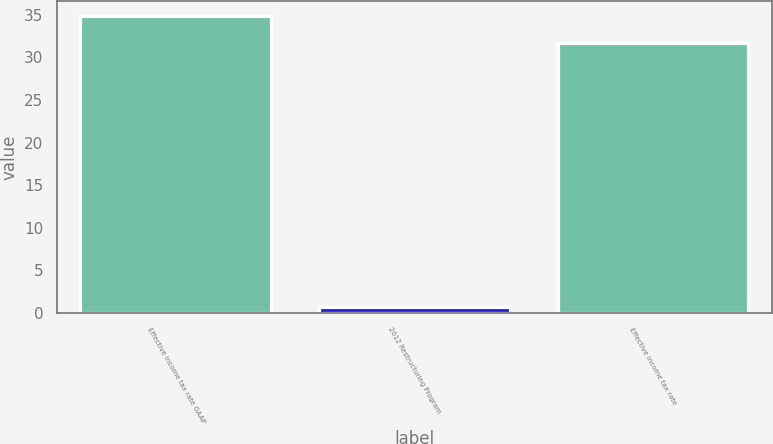Convert chart to OTSL. <chart><loc_0><loc_0><loc_500><loc_500><bar_chart><fcel>Effective income tax rate GAAP<fcel>2012 Restructuring Program<fcel>Effective income tax rate<nl><fcel>34.87<fcel>0.7<fcel>31.7<nl></chart> 